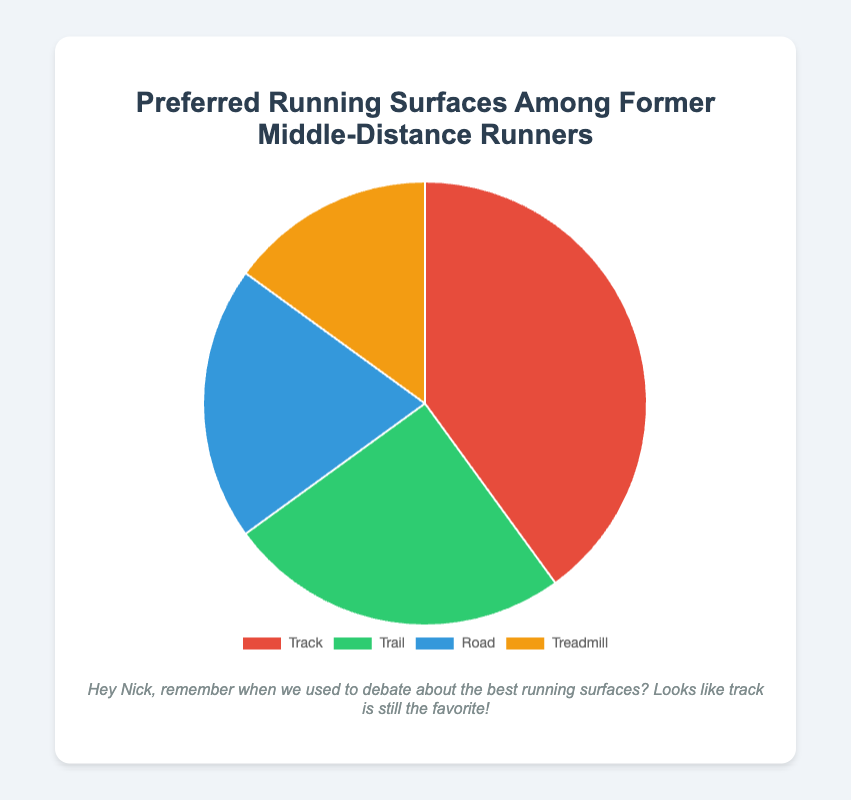Which surface is preferred by the majority of former middle-distance runners? Observe the pie chart and identify the segment with the largest percentage. In this case, Track has the largest segment.
Answer: Track How much more popular is Track compared to Treadmill? Subtract the percentage of former middle-distance runners who prefer Treadmill from those who prefer Track: 40% - 15% = 25%.
Answer: 25% What is the combined preference for Trail and Road? Add the percentages of Trail and Road: 25% + 20% = 45%.
Answer: 45% Is Road preferred by more runners than Treadmill? Compare the percentages of Road and Treadmill: 20% (Road) is greater than 15% (Treadmill).
Answer: Yes What percentage of former middle-distance runners prefer surfaces other than Track? Subtract Track's percentage from 100%: 100% - 40% = 60%.
Answer: 60% Which color represents Trail in the pie chart? Identify the color associated with the Trail segment in the pie chart. The segment for Trail is green.
Answer: Green What is the difference between the preferences for Trail and Road? Subtract the percentage of runners who prefer Road from those who prefer Trail: 25% - 20% = 5%.
Answer: 5% Which two surfaces have a combined preference that equals the preference for Track? Determine which two surfaces' combined percentages equal 40%. Trail (25%) and Road (20%) together sum to 45% which is closest.
Answer: Trail and Road What is the least preferred running surface? Identify the segment with the smallest percentage. In this case, Treadmill has the smallest segment.
Answer: Treadmill What fraction represents the preference for Road relative to the entire chart? Determine the preference for Road out of the total. Road is 20% of the total, so the fraction is 20/100 or simplified to 1/5.
Answer: 1/5 